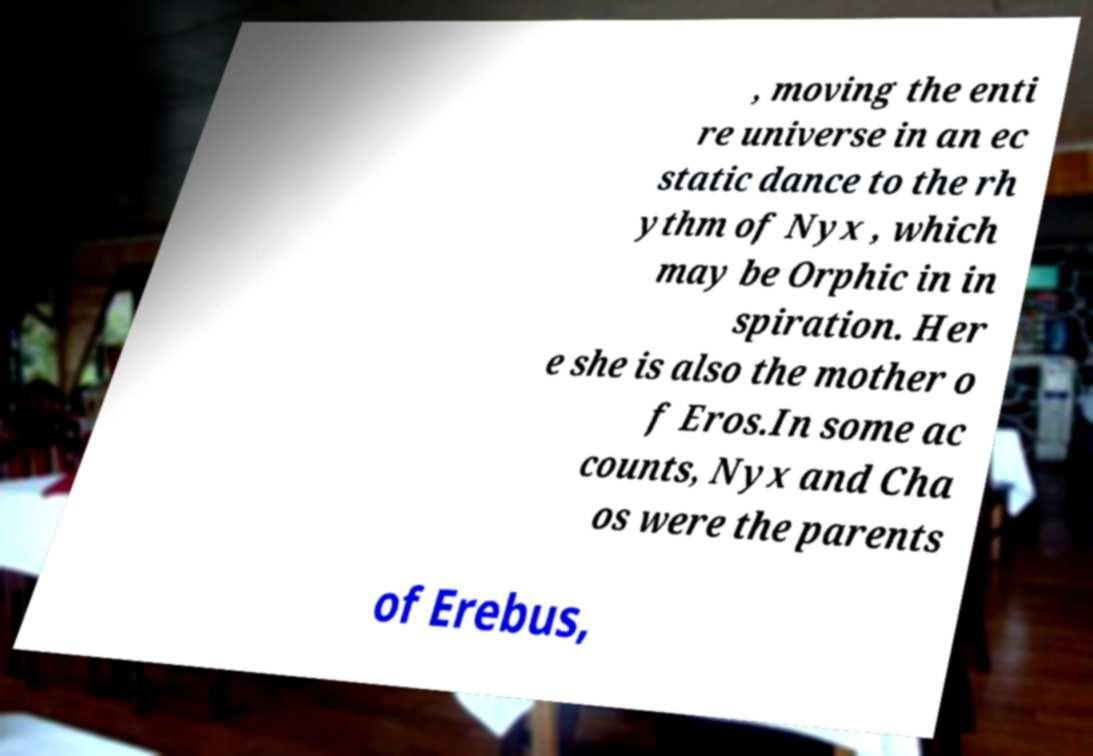Could you extract and type out the text from this image? , moving the enti re universe in an ec static dance to the rh ythm of Nyx , which may be Orphic in in spiration. Her e she is also the mother o f Eros.In some ac counts, Nyx and Cha os were the parents of Erebus, 